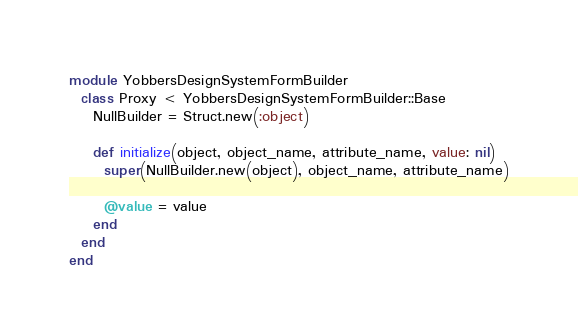<code> <loc_0><loc_0><loc_500><loc_500><_Ruby_>
module YobbersDesignSystemFormBuilder
  class Proxy < YobbersDesignSystemFormBuilder::Base
    NullBuilder = Struct.new(:object)

    def initialize(object, object_name, attribute_name, value: nil)
      super(NullBuilder.new(object), object_name, attribute_name)

      @value = value
    end
  end
end
</code> 